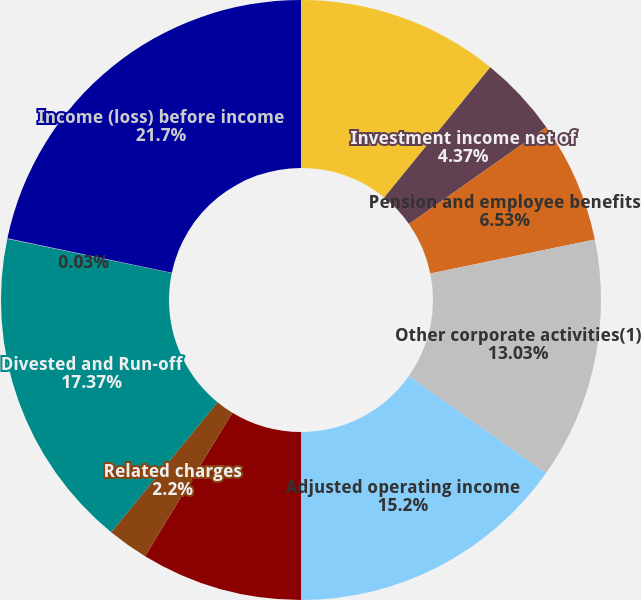Convert chart. <chart><loc_0><loc_0><loc_500><loc_500><pie_chart><fcel>Capital debt interest expense<fcel>Investment income net of<fcel>Pension and employee benefits<fcel>Other corporate activities(1)<fcel>Adjusted operating income<fcel>Realized investment gains<fcel>Related charges<fcel>Divested and Run-off<fcel>Unnamed: 8<fcel>Income (loss) before income<nl><fcel>10.87%<fcel>4.37%<fcel>6.53%<fcel>13.03%<fcel>15.2%<fcel>8.7%<fcel>2.2%<fcel>17.37%<fcel>0.03%<fcel>21.7%<nl></chart> 